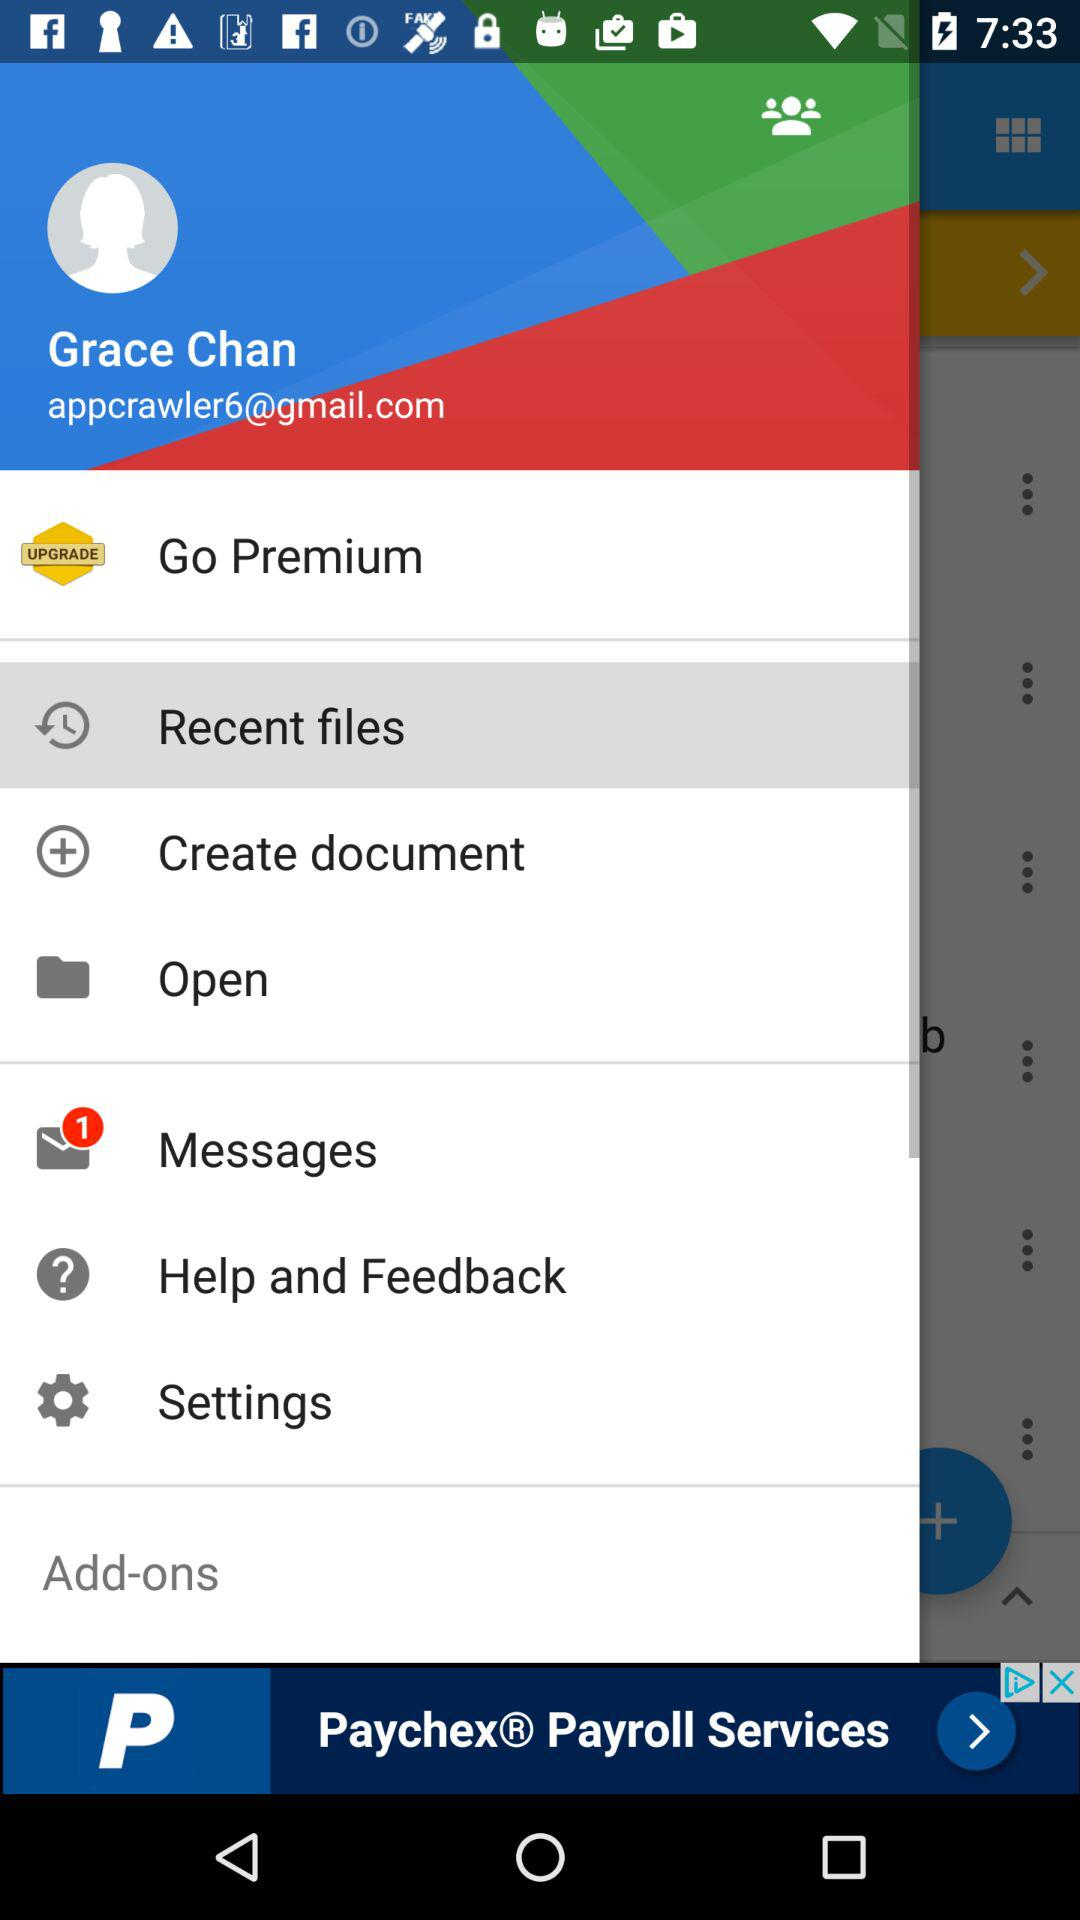How many unread messages are there? There is 1 unread message. 